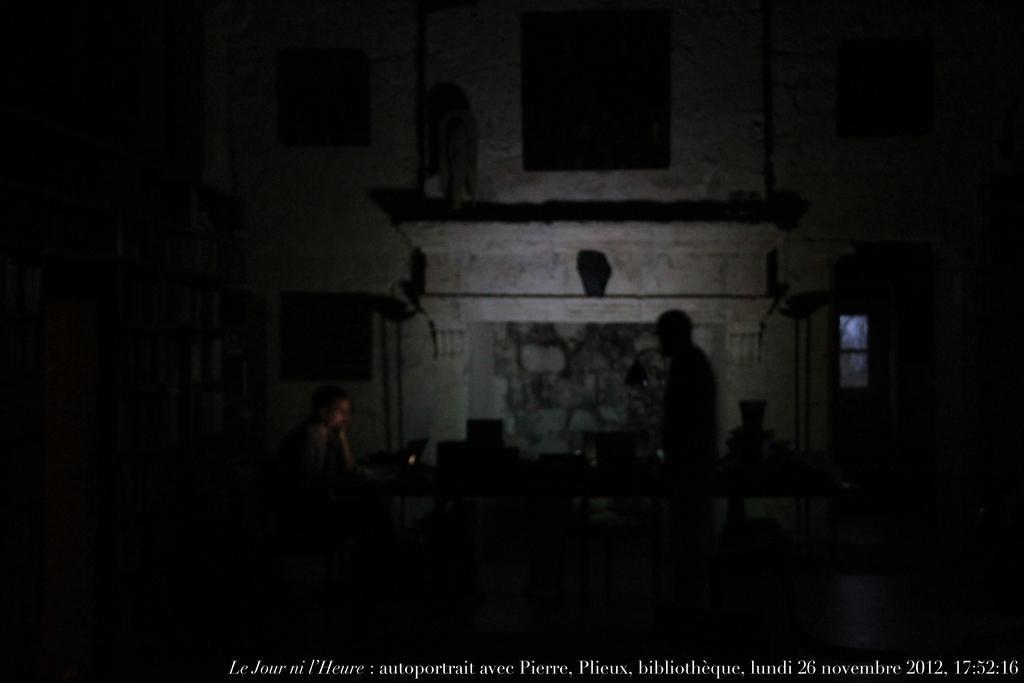Describe this image in one or two sentences. This is a black and white image in this image a person sitting on chair and another person is standing between them there is table, on that table there are objects, in the background there is a building at the bottom there is some text. 